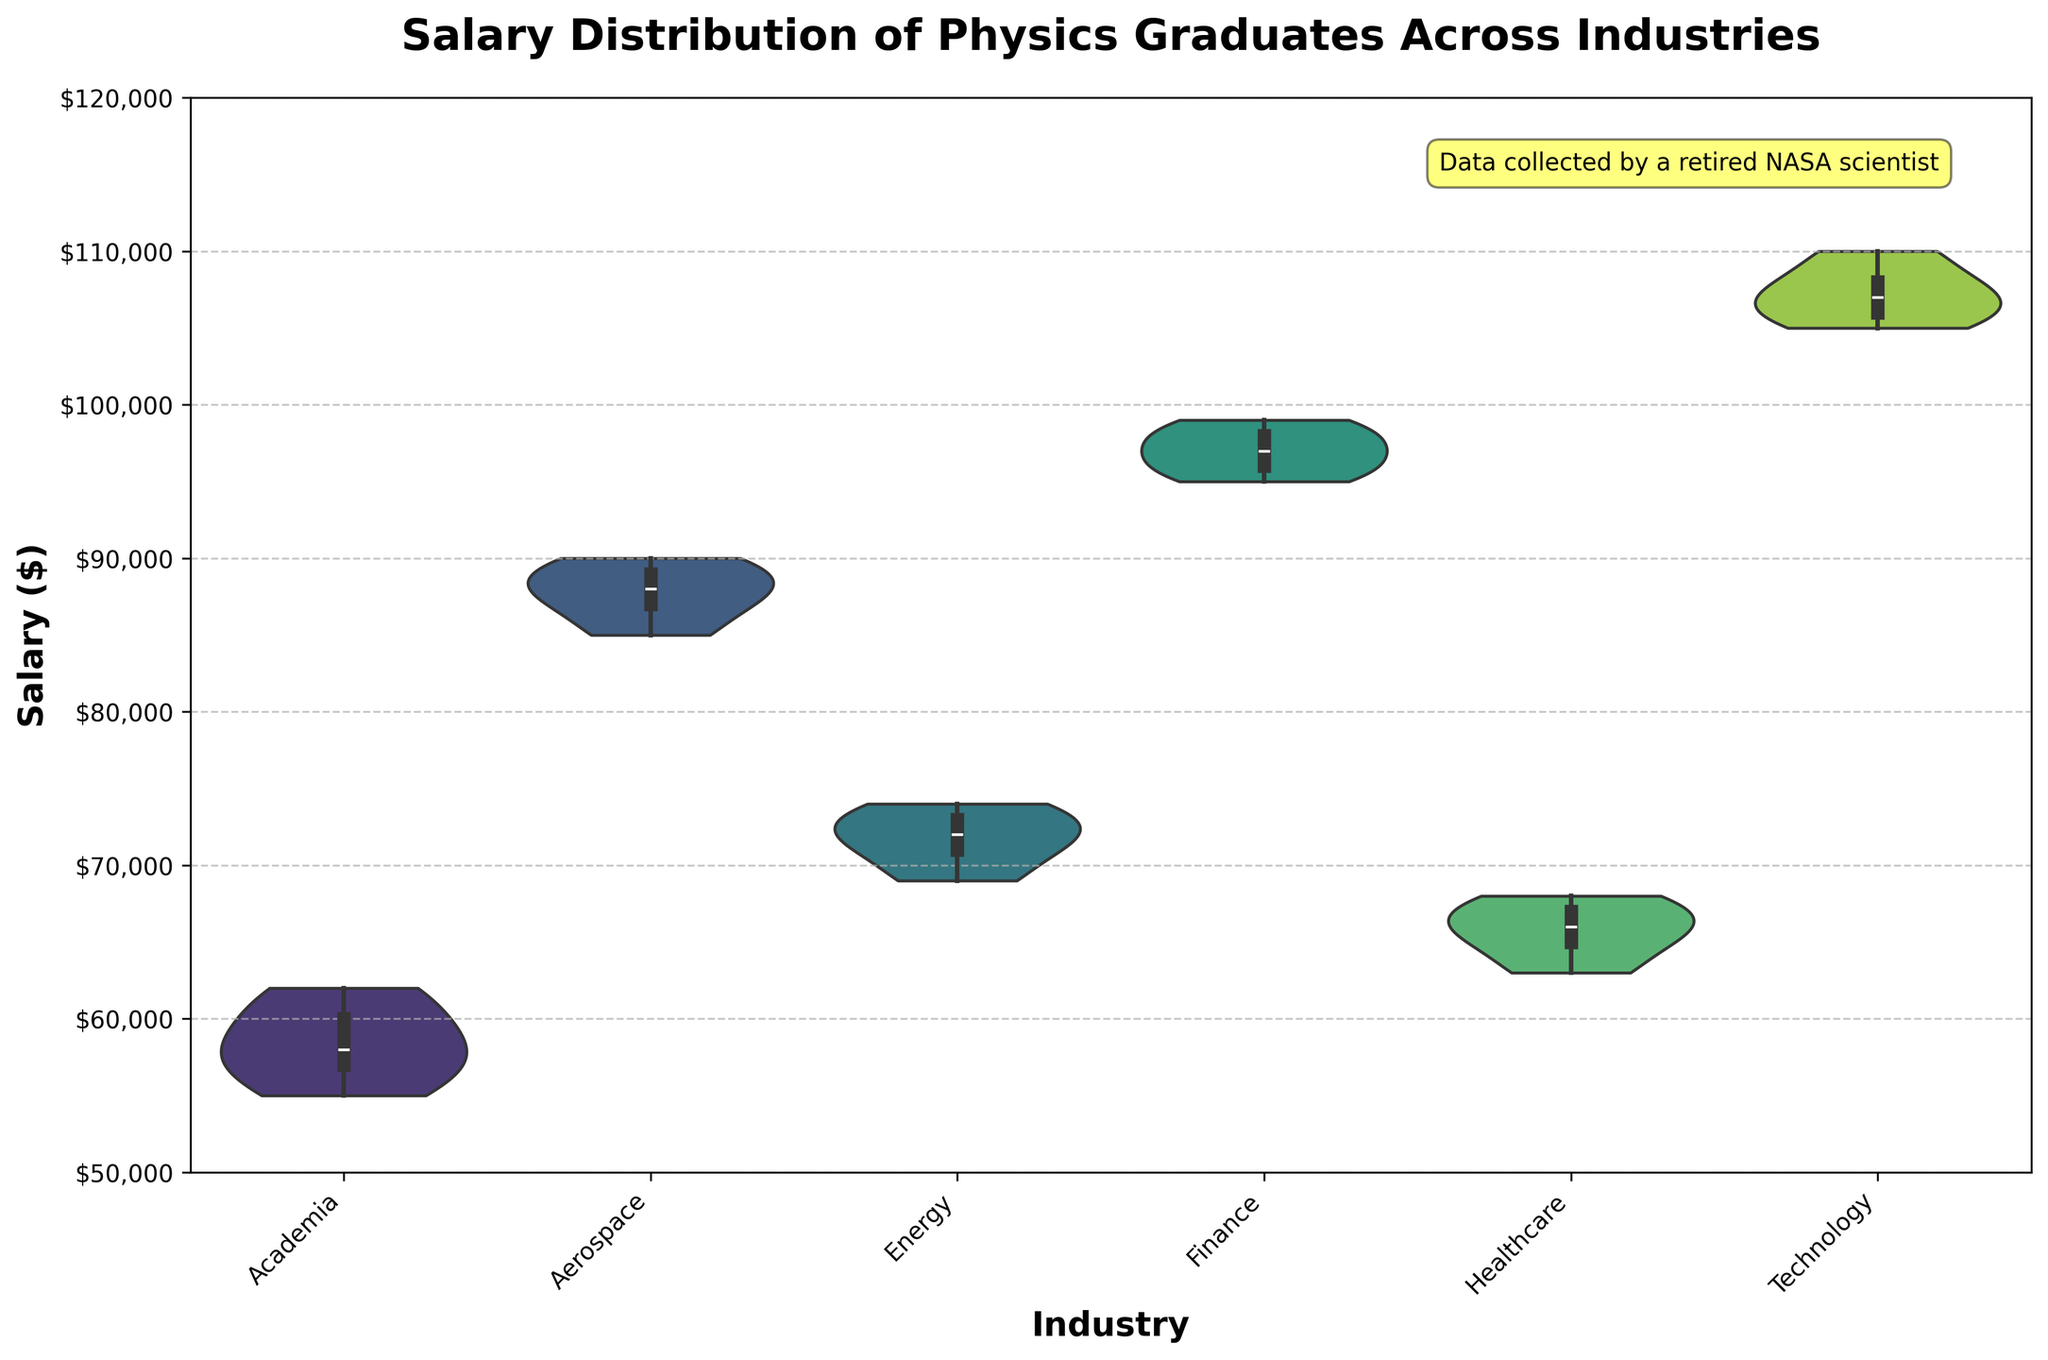What is the title of the violin plot? The title is the text at the top of the figure, which describes what the plot is about.
Answer: Salary Distribution of Physics Graduates Across Industries Which industry has the highest median salary? You can identify the median salary by looking at the white dot inside each violin. The white dot for the Technology industry is at the highest position compared to the others.
Answer: Technology What is the range of salaries in the Healthcare industry? The range of salaries in the Healthcare industry can be observed by noting the extent from the bottom to the top of the violin.
Answer: $63,000 to $68,000 How does the salary distribution in the Academia industry compare to that in the Finance industry? The violin for Finance is higher and more spread out compared to Academia, indicating higher and more varied salaries in Finance compared to Academia.
Answer: Finance has higher and more varied salaries Which industry appears to have the most narrow salary distribution? The narrowest violin indicates the most narrow salary distribution, which is seen in Healthcare.
Answer: Healthcare Are there any outliers in the Technology industry salary distribution? Outliers would be indicated by points outside the range covered by the violin. There are no visible points outside the range in Technology, implying no outliers.
Answer: No What is the lowest salary in the Energy industry? The lowest point of the violin in the Energy industry gives the minimum salary, which appears to be $69,000.
Answer: $69,000 How does the average salary in Aerospace compare to that in Energy? The violins' central white dots mark the median, not the average, but since the distribution in both industries is fairly symmetric, the median can act as a good proxy. The median for Aerospace appears higher than for Energy.
Answer: Higher in Aerospace Which industry has the smallest interquartile range (IQR) for salaries? The IQR is the range between the first and third quartiles, which is the width of the box inside each violin. Healthcare shows the smallest IQR.
Answer: Healthcare What additional information is provided in the text box on the plot? The text box mentions that the data was collected by a retired NASA scientist.
Answer: Data collected by a retired NASA scientist 